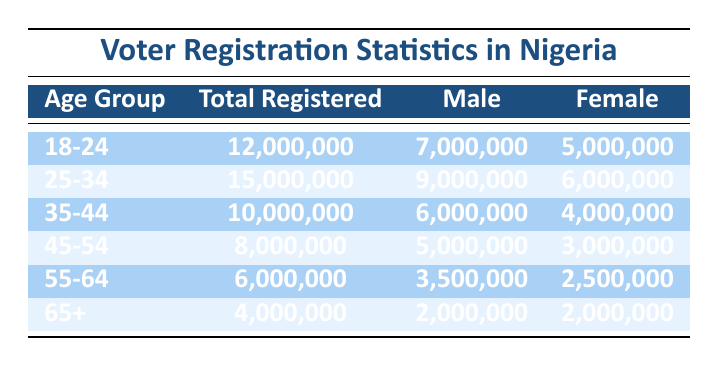What is the total number of voters registered in the age group 25-34? The table states that the total number of voters registered in the age group 25-34 is clearly listed under "Total Registered" for that age group, which is 15,000,000.
Answer: 15,000,000 How many females are registered to vote in the 18-24 age group? In the table, under the 18-24 age group, the number of females is specifically indicated as 5,000,000.
Answer: 5,000,000 Is the number of male voters in the 45-54 group greater than the number of female voters in the same group? The table shows that there are 5,000,000 male voters and 3,000,000 female voters in the 45-54 age group. Since 5,000,000 is greater than 3,000,000, the answer is yes.
Answer: Yes What is the average number of registered voters across all age groups? To find the average, sum the total registered voters from each age group: 12,000,000 + 15,000,000 + 10,000,000 + 8,000,000 + 6,000,000 + 4,000,000 = 55,000,000. There are 6 age groups, so the average is 55,000,000 / 6 = 9,166,667.
Answer: 9,166,667 What is the total number of registered voters for all age groups combined? The total number of registered voters is found by adding the values for "Total Registered" across all age groups: 12,000,000 + 15,000,000 + 10,000,000 + 8,000,000 + 6,000,000 + 4,000,000 = 55,000,000.
Answer: 55,000,000 Are there more male voters than female voters in the age group 35-44? In the 35-44 age group, the table indicates that there are 6,000,000 male voters and 4,000,000 female voters. Since 6,000,000 is greater than 4,000,000, the answer is yes.
Answer: Yes What is the difference in the number of registered male voters between the age groups 25-34 and 55-64? From the table, the number of registered male voters in the 25-34 age group is 9,000,000, and in the 55-64 age group, it is 3,500,000. Calculating the difference: 9,000,000 - 3,500,000 = 5,500,000.
Answer: 5,500,000 How many voters aged 65 and older are registered in total? The total number of registered voters in the 65+ age group is explicitly stated in the table under "Total Registered," which is 4,000,000.
Answer: 4,000,000 